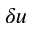<formula> <loc_0><loc_0><loc_500><loc_500>\delta u</formula> 